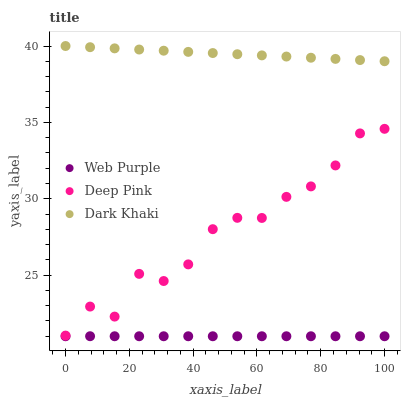Does Web Purple have the minimum area under the curve?
Answer yes or no. Yes. Does Dark Khaki have the maximum area under the curve?
Answer yes or no. Yes. Does Deep Pink have the minimum area under the curve?
Answer yes or no. No. Does Deep Pink have the maximum area under the curve?
Answer yes or no. No. Is Dark Khaki the smoothest?
Answer yes or no. Yes. Is Deep Pink the roughest?
Answer yes or no. Yes. Is Web Purple the smoothest?
Answer yes or no. No. Is Web Purple the roughest?
Answer yes or no. No. Does Web Purple have the lowest value?
Answer yes or no. Yes. Does Deep Pink have the lowest value?
Answer yes or no. No. Does Dark Khaki have the highest value?
Answer yes or no. Yes. Does Deep Pink have the highest value?
Answer yes or no. No. Is Web Purple less than Dark Khaki?
Answer yes or no. Yes. Is Dark Khaki greater than Web Purple?
Answer yes or no. Yes. Does Web Purple intersect Dark Khaki?
Answer yes or no. No. 